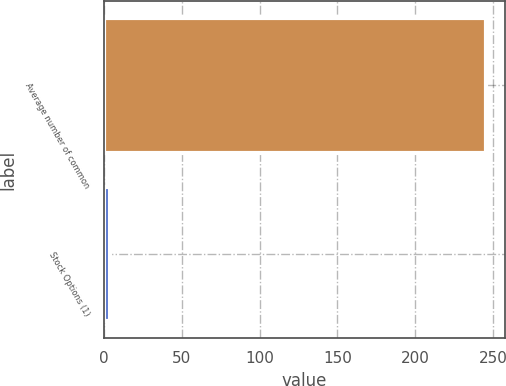Convert chart to OTSL. <chart><loc_0><loc_0><loc_500><loc_500><bar_chart><fcel>Average number of common<fcel>Stock Options (1)<nl><fcel>245.34<fcel>3.9<nl></chart> 